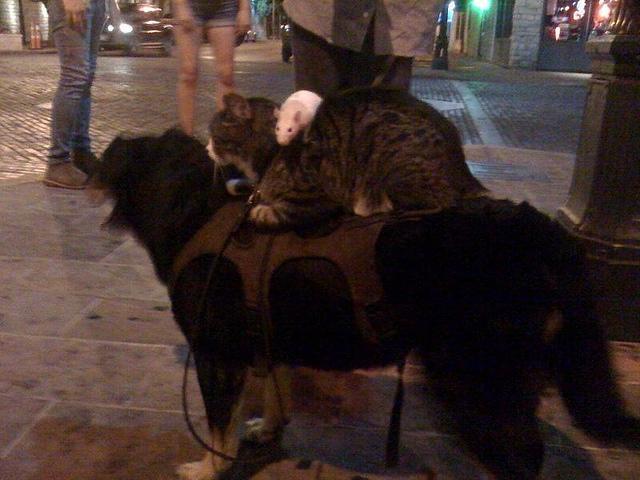How many cats are in the photo?
Give a very brief answer. 1. How many people are there?
Give a very brief answer. 3. 